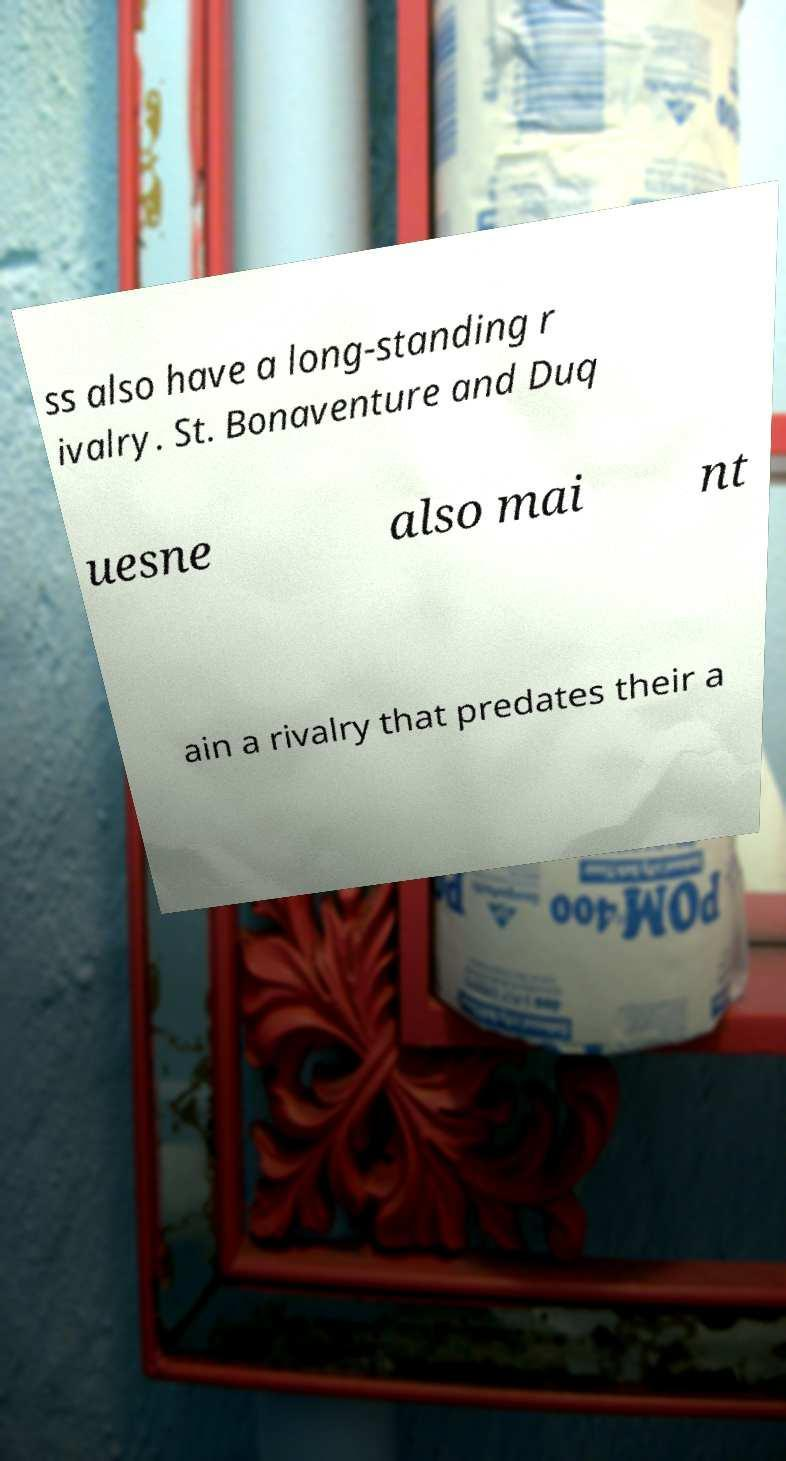There's text embedded in this image that I need extracted. Can you transcribe it verbatim? ss also have a long-standing r ivalry. St. Bonaventure and Duq uesne also mai nt ain a rivalry that predates their a 